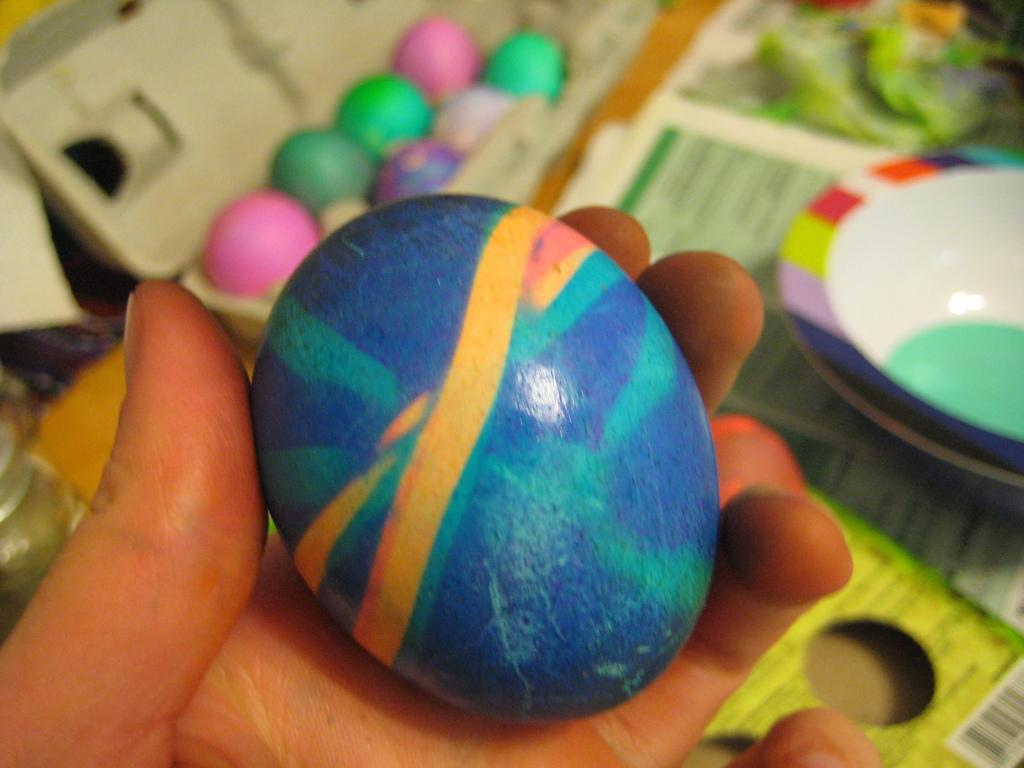What is on the person's hand in the image? There is an object on a person's hand in the image. What can be seen in the background of the image? In the background of the image, there is a bowl, papers, and other objects. Can you describe the other objects in the background? Unfortunately, the provided facts do not give specific details about the other objects in the background. What type of wing is visible on the person's hand in the image? There is no wing visible on the person's hand in the image. What treatment is being administered to the person in the image? The provided facts do not give any information about a treatment being administered to the person in the image. 